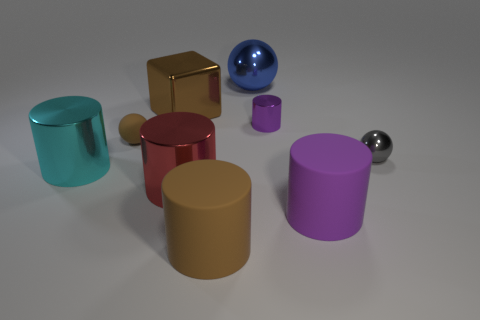Subtract all large cylinders. How many cylinders are left? 1 Subtract all cyan cylinders. How many cylinders are left? 4 Subtract all cubes. How many objects are left? 8 Subtract 3 cylinders. How many cylinders are left? 2 Subtract all tiny brown matte balls. Subtract all red cylinders. How many objects are left? 7 Add 3 purple metallic objects. How many purple metallic objects are left? 4 Add 4 big gray cylinders. How many big gray cylinders exist? 4 Add 1 large blue things. How many objects exist? 10 Subtract 0 yellow spheres. How many objects are left? 9 Subtract all yellow cubes. Subtract all brown balls. How many cubes are left? 1 